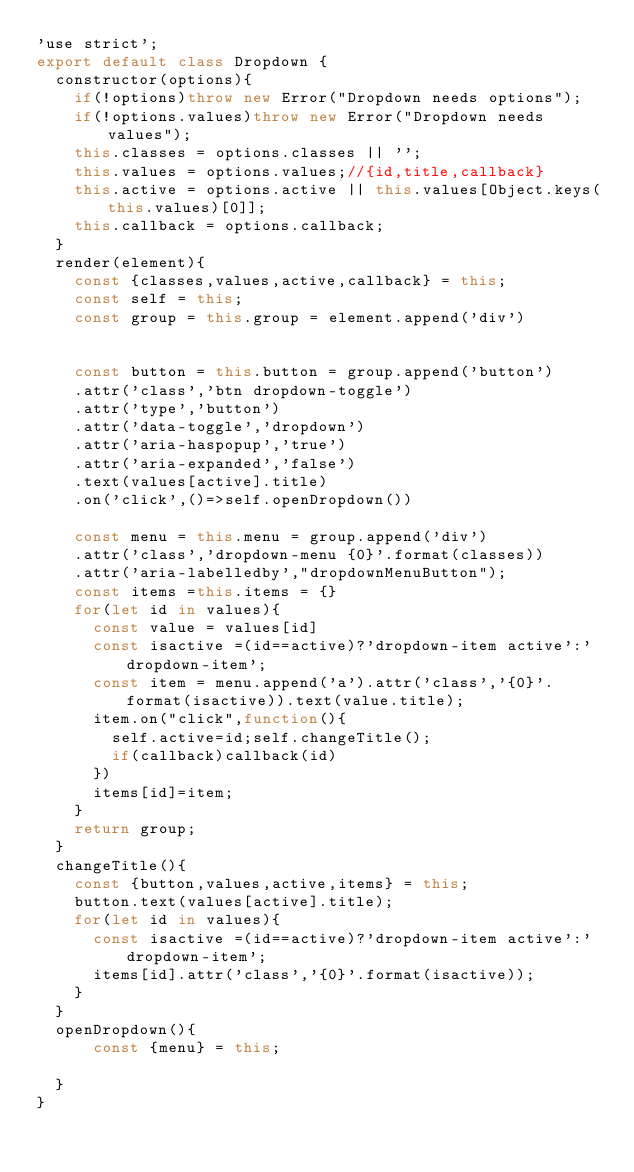Convert code to text. <code><loc_0><loc_0><loc_500><loc_500><_JavaScript_>'use strict';
export default class Dropdown {
  constructor(options){
    if(!options)throw new Error("Dropdown needs options");   
    if(!options.values)throw new Error("Dropdown needs values");   
    this.classes = options.classes || '';   
    this.values = options.values;//{id,title,callback}
    this.active = options.active || this.values[Object.keys(this.values)[0]];
    this.callback = options.callback;
  }
  render(element){
    const {classes,values,active,callback} = this;   
    const self = this;
    const group = this.group = element.append('div')
   
    
    const button = this.button = group.append('button')
    .attr('class','btn dropdown-toggle')
    .attr('type','button')
    .attr('data-toggle','dropdown')
    .attr('aria-haspopup','true')
    .attr('aria-expanded','false')
    .text(values[active].title)
    .on('click',()=>self.openDropdown())
    
    const menu = this.menu = group.append('div')
    .attr('class','dropdown-menu {0}'.format(classes))
    .attr('aria-labelledby',"dropdownMenuButton");
    const items =this.items = {}
    for(let id in values){
      const value = values[id]
      const isactive =(id==active)?'dropdown-item active':'dropdown-item';
      const item = menu.append('a').attr('class','{0}'.format(isactive)).text(value.title);
      item.on("click",function(){
        self.active=id;self.changeTitle();
        if(callback)callback(id)
      })
      items[id]=item;
    }
    return group;
  }
  changeTitle(){
    const {button,values,active,items} = this;
    button.text(values[active].title);
    for(let id in values){      
      const isactive =(id==active)?'dropdown-item active':'dropdown-item';
      items[id].attr('class','{0}'.format(isactive));      
    }
  }
  openDropdown(){
      const {menu} = this;
      
  }
}</code> 